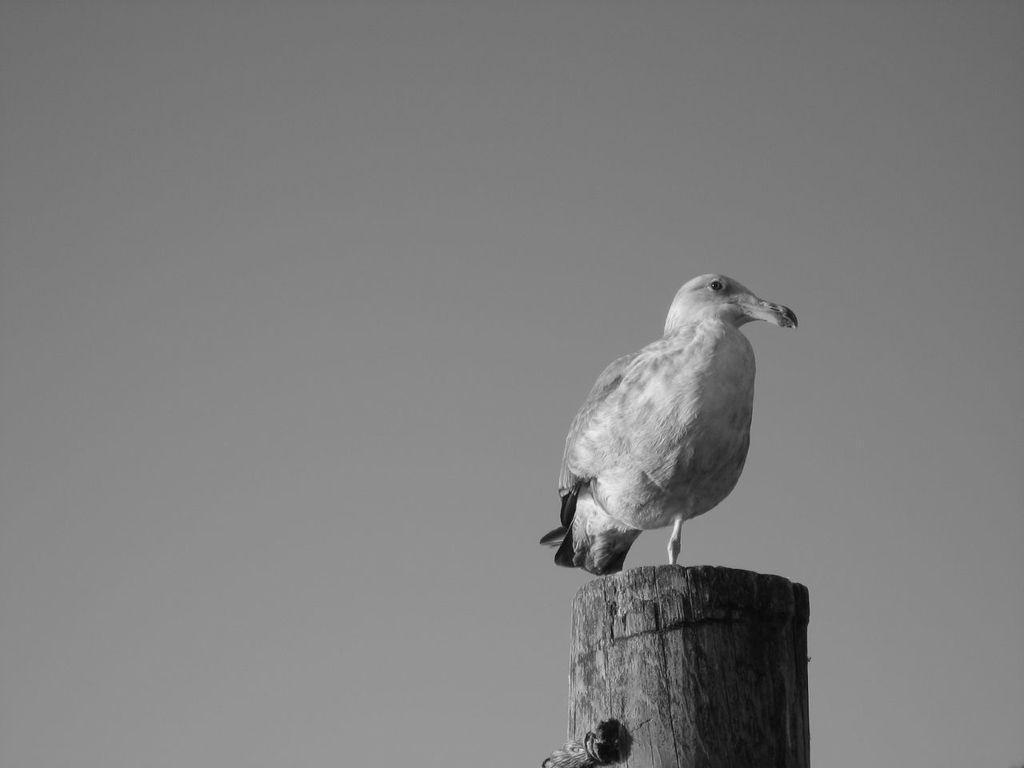Could you give a brief overview of what you see in this image? This image consists of a bird on a wooden block. In the background, it looks like sky. 